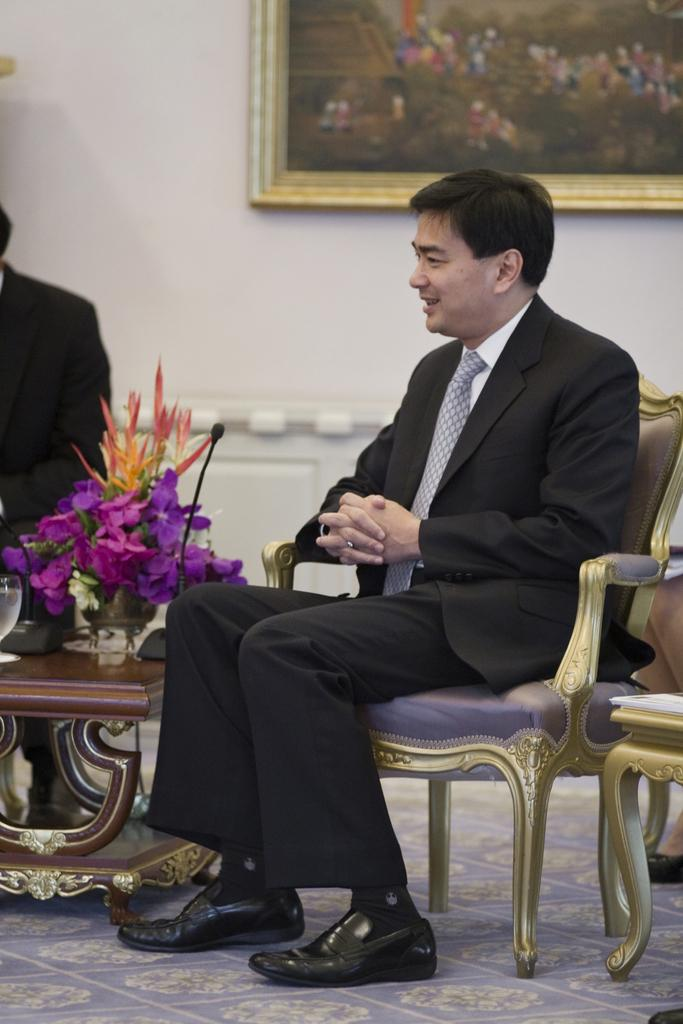What is the man in the image doing? The man is sitting on a chair in the image. How does the man appear in the image? The man has a smile on his face. What objects can be seen on the table in the image? There is a flower vase and a microphone on the table. What is hanging on the wall in the image? There is a photo frame on the wall. Can you see any fairies flying around the man in the image? No, there are no fairies present in the image. What type of stitch is being used to hold the boundary of the photo frame in the image? There is no stitching or boundary visible in the photo frame in the image; it is a flat, framed picture. 